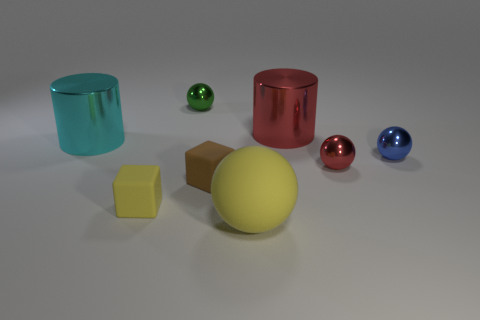Subtract all tiny blue metal balls. How many balls are left? 3 Add 1 spheres. How many objects exist? 9 Subtract all green spheres. How many spheres are left? 3 Subtract all green balls. Subtract all blue cylinders. How many balls are left? 3 Subtract all green balls. How many purple blocks are left? 0 Subtract all blue metal objects. Subtract all cylinders. How many objects are left? 5 Add 5 cyan metallic cylinders. How many cyan metallic cylinders are left? 6 Add 6 large red shiny cylinders. How many large red shiny cylinders exist? 7 Subtract 1 yellow blocks. How many objects are left? 7 Subtract all blocks. How many objects are left? 6 